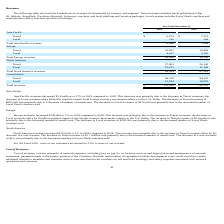From Travelzoo's financial document, What is the total revenues from Asia Pacific in 2019 and 2018 respectively? The document shows two values: 6,490 and 7,859 (in thousands). From the document: "Total Asia Pacific revenues 6,490 7,859 Total Asia Pacific revenues 6,490 7,859..." Also, What is the total revenues from Europe in 2019 and 2018 respectively? The document shows two values: 36,898 and 36,149 (in thousands). From the document: "Total Europe revenues 36,898 36,149 Total Europe revenues 36,898 36,149..." Also, What is the total revenues from North America in 2019 and 2018 respectively? The document shows two values: 68,024 and 67,314 (in thousands). From the document: "Total North America revenues 68,024 67,314 Total North America revenues 68,024 67,314..." Also, In 2019, how many geographic regions have total revenues of more than $5,000 thousand? Counting the relevant items in the document: Asia Pacific ,  Europe ,  North America, I find 3 instances. The key data points involved are: Asia Pacific, Europe, North America. Also, can you calculate: What is the change in the total North America revenue between 2018 and 2019? Based on the calculation: 68,024-67,314, the result is 710 (in thousands). This is based on the information: "Total North America revenues 68,024 67,314 Total North America revenues 68,024 67,314..." The key data points involved are: 67,314, 68,024. Additionally, In 2018, which geographic region has the highest total revenue? According to the financial document, North America. The relevant text states: "North America..." 